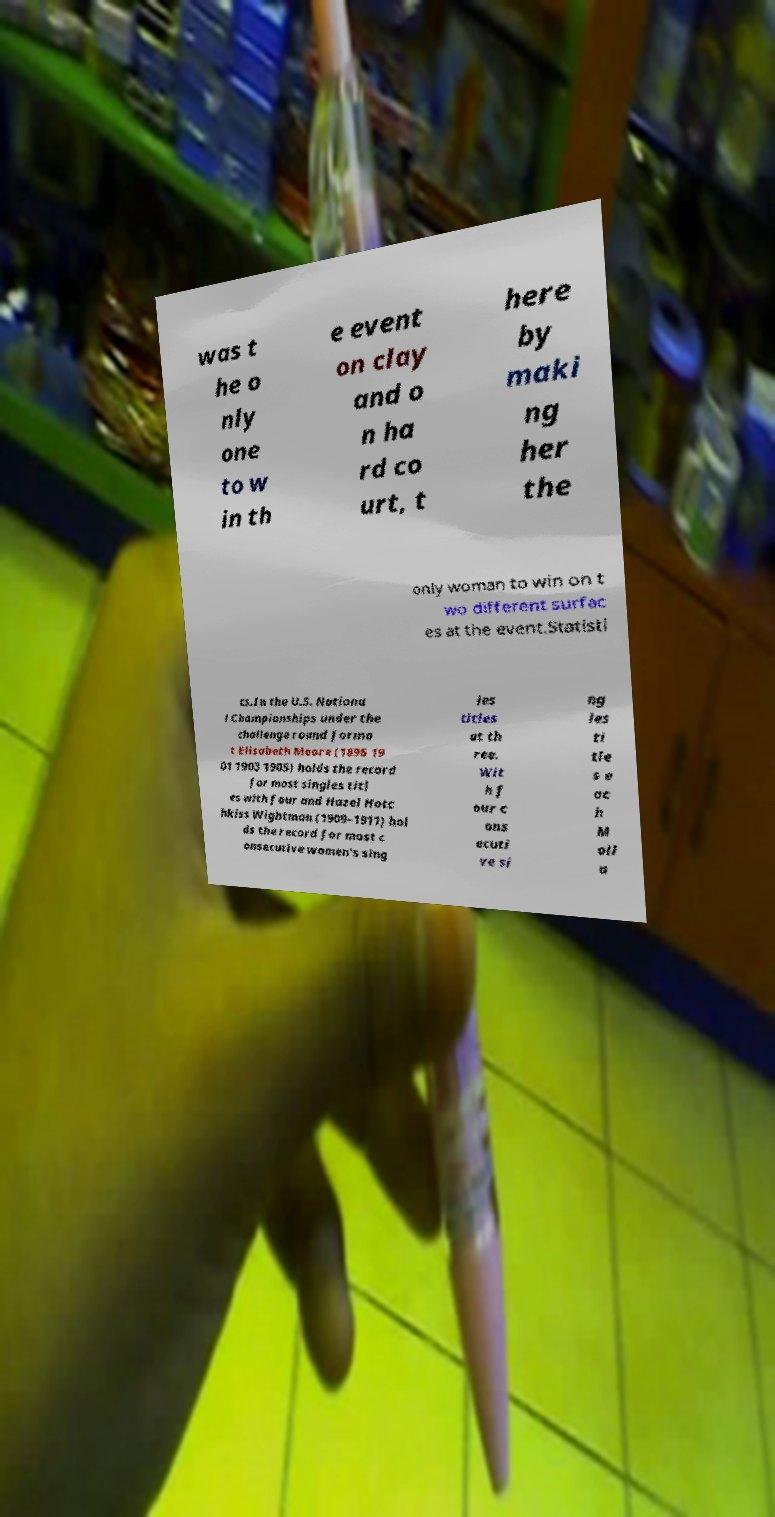There's text embedded in this image that I need extracted. Can you transcribe it verbatim? was t he o nly one to w in th e event on clay and o n ha rd co urt, t here by maki ng her the only woman to win on t wo different surfac es at the event.Statisti cs.In the U.S. Nationa l Championships under the challenge round forma t Elisabeth Moore (1896 19 01 1903 1905) holds the record for most singles titl es with four and Hazel Hotc hkiss Wightman (1909–1911) hol ds the record for most c onsecutive women's sing les titles at th ree. Wit h f our c ons ecuti ve si ng les ti tle s e ac h M oll a 